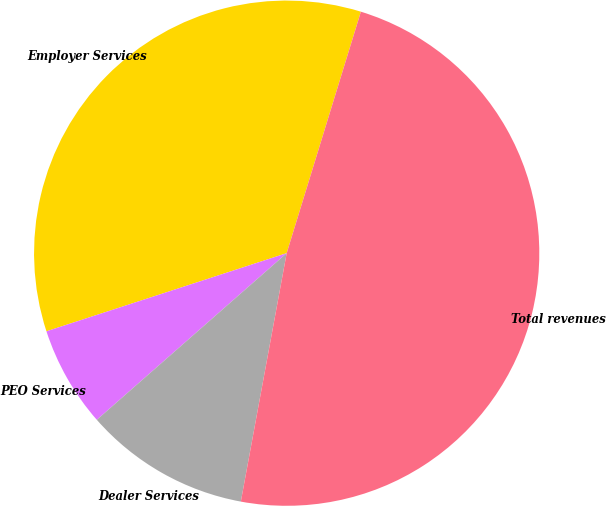Convert chart to OTSL. <chart><loc_0><loc_0><loc_500><loc_500><pie_chart><fcel>Employer Services<fcel>PEO Services<fcel>Dealer Services<fcel>Total revenues<nl><fcel>34.75%<fcel>6.46%<fcel>10.63%<fcel>48.16%<nl></chart> 